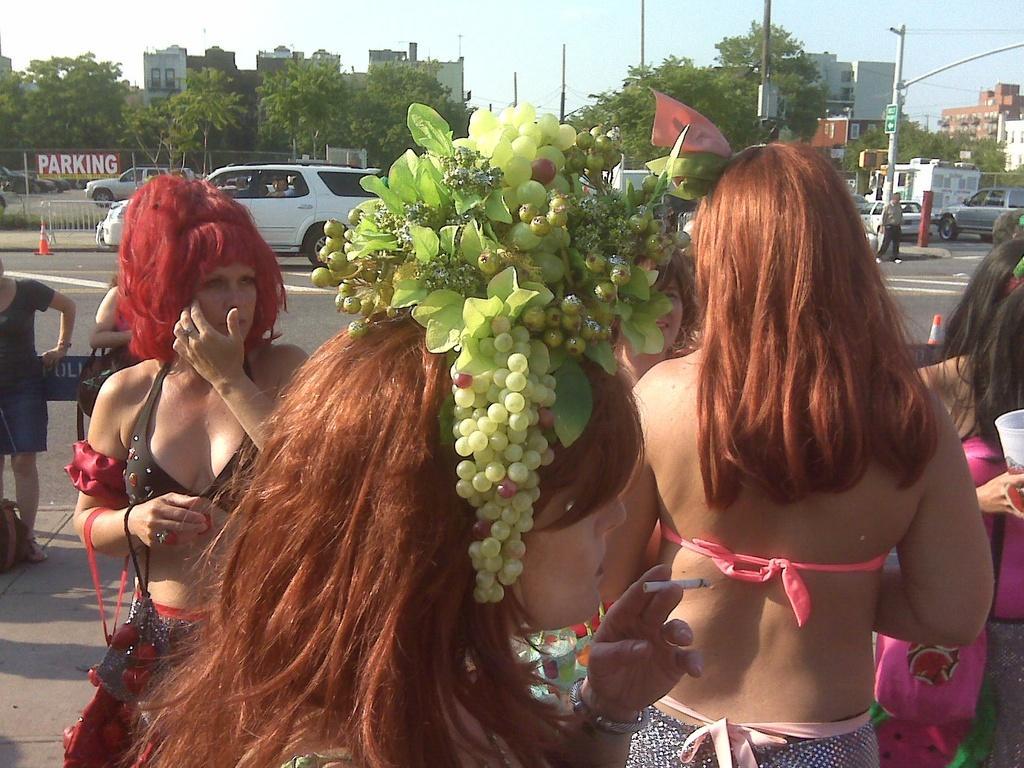How would you summarize this image in a sentence or two? In this image I can see few women are standing on the road. This woman is wearing a head band on her head which is made with some fruits and flowers. In the background I can see the trees and buildings. On the road there are some vehicles. 